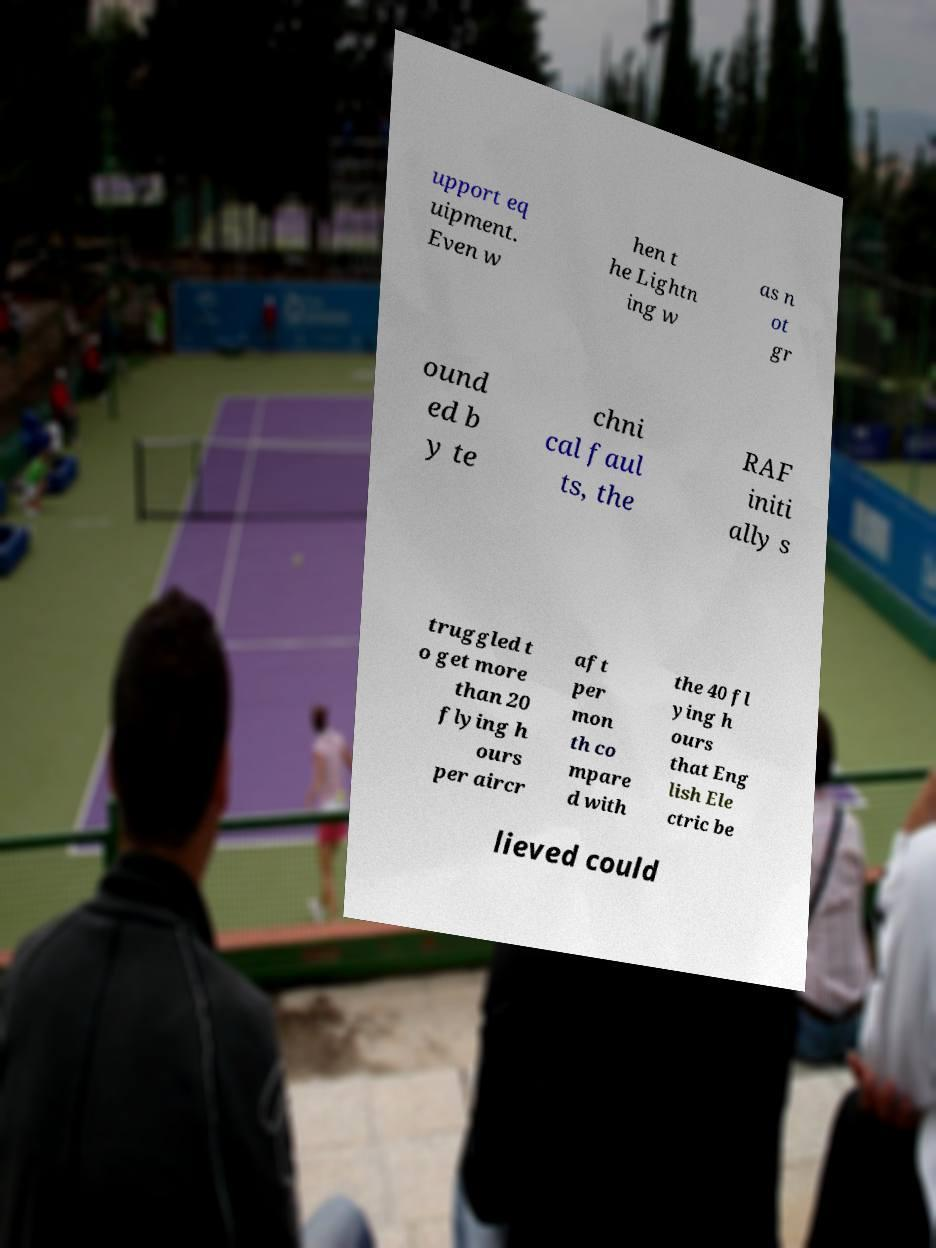There's text embedded in this image that I need extracted. Can you transcribe it verbatim? upport eq uipment. Even w hen t he Lightn ing w as n ot gr ound ed b y te chni cal faul ts, the RAF initi ally s truggled t o get more than 20 flying h ours per aircr aft per mon th co mpare d with the 40 fl ying h ours that Eng lish Ele ctric be lieved could 